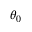<formula> <loc_0><loc_0><loc_500><loc_500>\theta _ { 0 }</formula> 